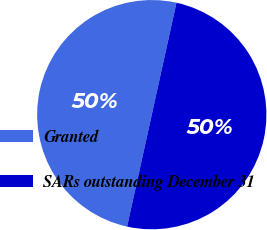<chart> <loc_0><loc_0><loc_500><loc_500><pie_chart><fcel>Granted<fcel>SARs outstanding December 31<nl><fcel>50.0%<fcel>50.0%<nl></chart> 